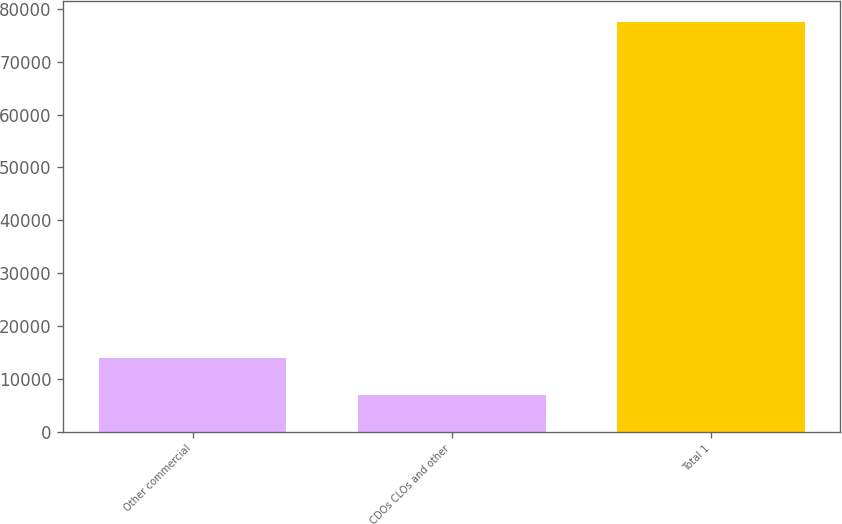Convert chart to OTSL. <chart><loc_0><loc_0><loc_500><loc_500><bar_chart><fcel>Other commercial<fcel>CDOs CLOs and other<fcel>Total 1<nl><fcel>13931.2<fcel>6861<fcel>77563<nl></chart> 